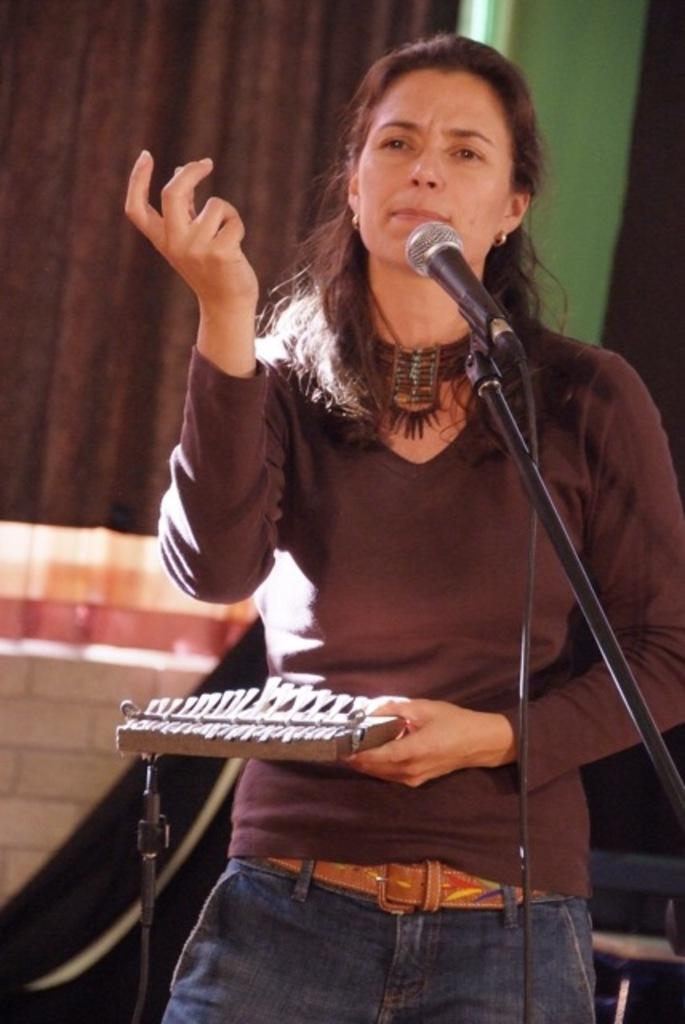Please provide a concise description of this image. In this picture I can observe a woman standing in front of a mic and a stand. She is wearing brown color T shirt. In the background I can observe brown color curtain and a wall. 